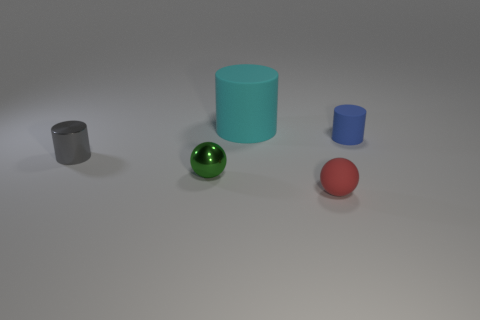Are there any matte things of the same size as the green metal sphere?
Ensure brevity in your answer.  Yes. There is a tiny cylinder that is left of the cylinder that is to the right of the tiny red ball; what is its material?
Give a very brief answer. Metal. What number of big matte cylinders are the same color as the shiny cylinder?
Provide a short and direct response. 0. There is a blue object that is made of the same material as the large cylinder; what is its shape?
Your answer should be compact. Cylinder. There is a metallic thing in front of the gray shiny cylinder; what size is it?
Your answer should be compact. Small. Are there the same number of cyan objects that are in front of the big cyan matte cylinder and small objects that are in front of the tiny blue rubber object?
Your answer should be very brief. No. What color is the matte object in front of the tiny cylinder in front of the rubber cylinder on the right side of the big cylinder?
Your answer should be very brief. Red. What number of objects are both left of the tiny blue matte thing and behind the small red matte sphere?
Provide a succinct answer. 3. There is a tiny rubber object behind the tiny gray metallic cylinder; is it the same color as the small sphere on the left side of the small red ball?
Provide a succinct answer. No. Are there any other things that have the same material as the big thing?
Your answer should be compact. Yes. 